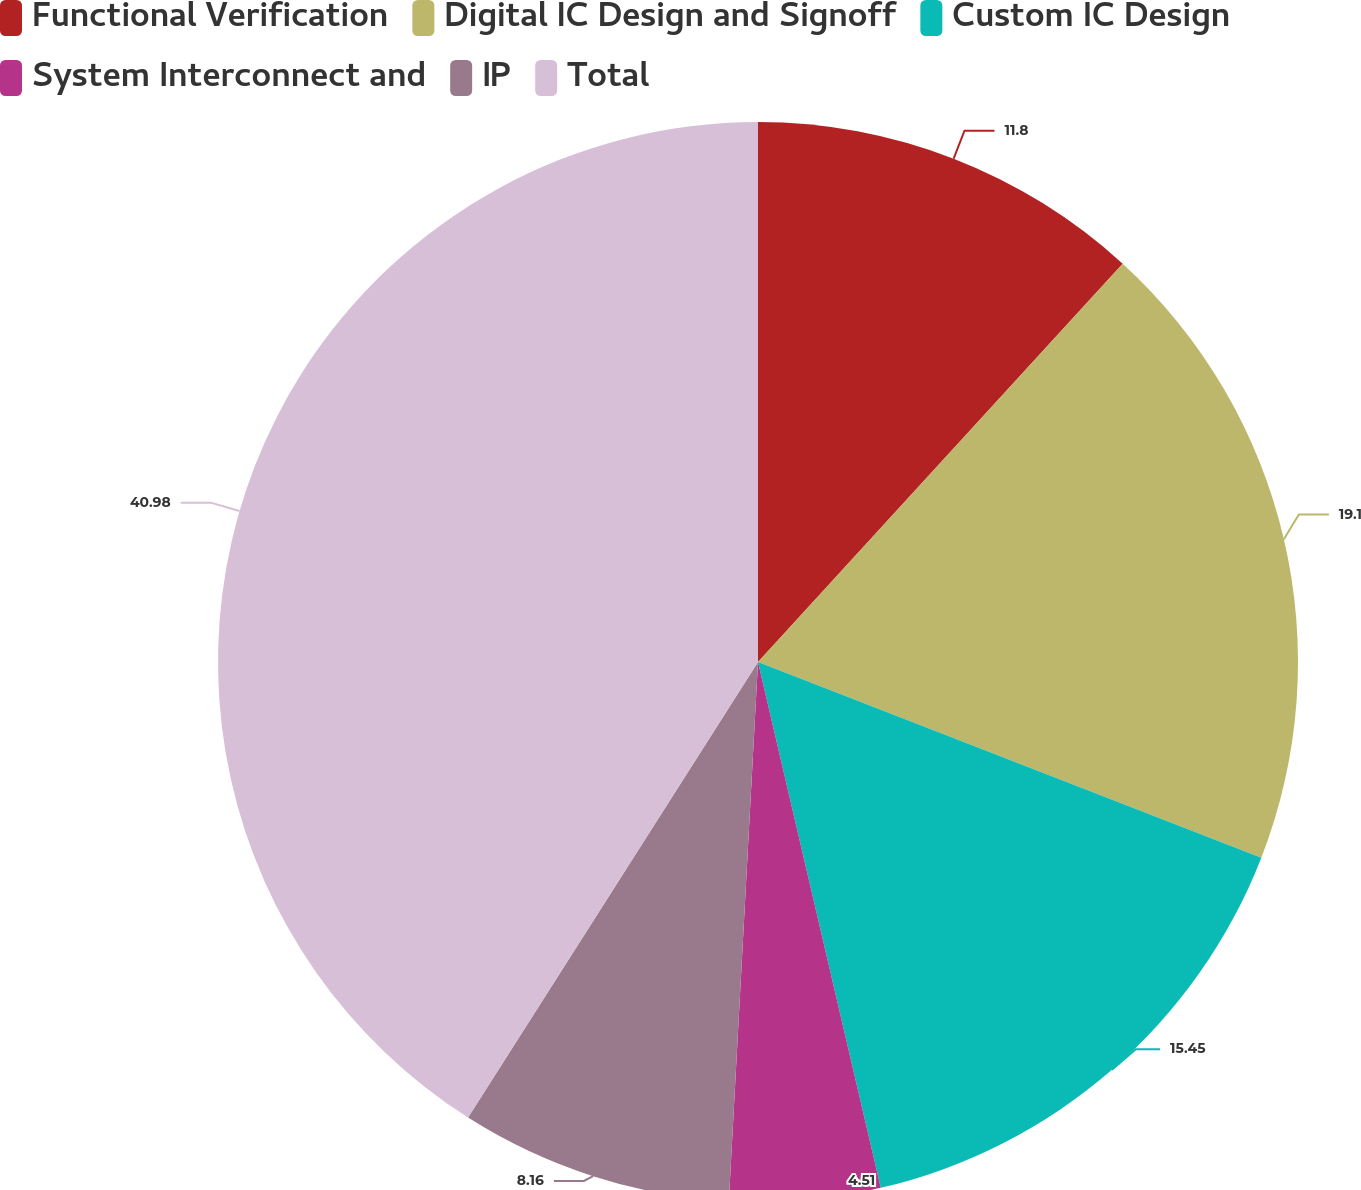<chart> <loc_0><loc_0><loc_500><loc_500><pie_chart><fcel>Functional Verification<fcel>Digital IC Design and Signoff<fcel>Custom IC Design<fcel>System Interconnect and<fcel>IP<fcel>Total<nl><fcel>11.8%<fcel>19.1%<fcel>15.45%<fcel>4.51%<fcel>8.16%<fcel>40.98%<nl></chart> 